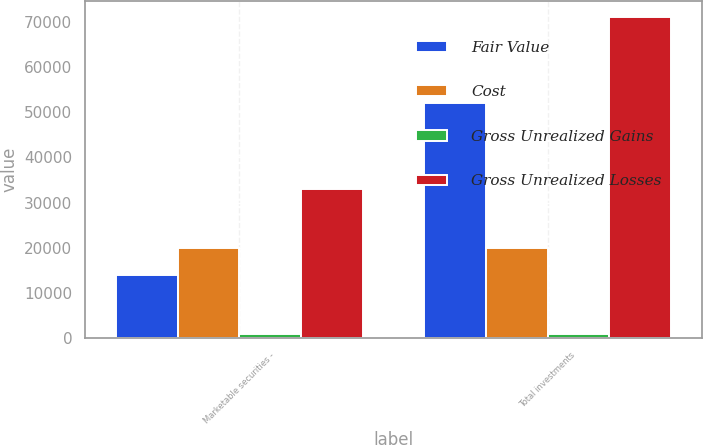Convert chart. <chart><loc_0><loc_0><loc_500><loc_500><stacked_bar_chart><ecel><fcel>Marketable securities -<fcel>Total investments<nl><fcel>Fair Value<fcel>13974<fcel>52150<nl><fcel>Cost<fcel>19912<fcel>19912<nl><fcel>Gross Unrealized Gains<fcel>889<fcel>889<nl><fcel>Gross Unrealized Losses<fcel>32997<fcel>71173<nl></chart> 